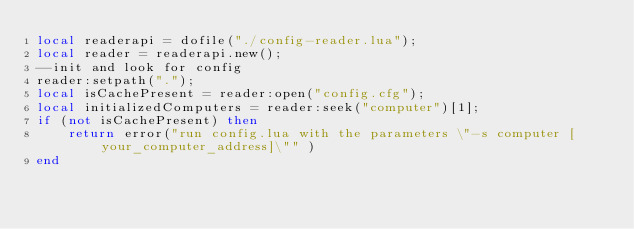Convert code to text. <code><loc_0><loc_0><loc_500><loc_500><_Lua_>local readerapi = dofile("./config-reader.lua");
local reader = readerapi.new();
--init and look for config
reader:setpath(".");
local isCachePresent = reader:open("config.cfg");
local initializedComputers = reader:seek("computer")[1];
if (not isCachePresent) then
    return error("run config.lua with the parameters \"-s computer [your_computer_address]\"" )
end</code> 